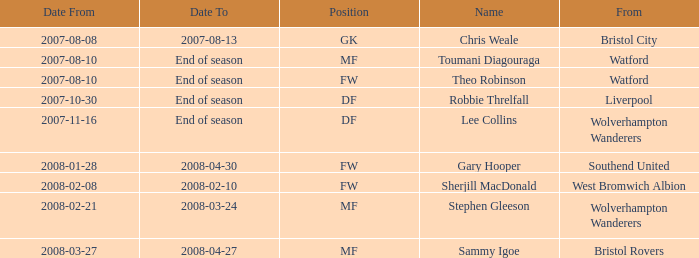What was the Date From for Theo Robinson, who was with the team until the end of season? 2007-08-10. 